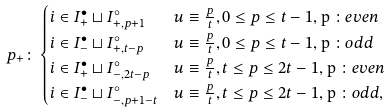Convert formula to latex. <formula><loc_0><loc_0><loc_500><loc_500>p _ { + } \colon & \begin{cases} i \in I ^ { \bullet } _ { + } \sqcup I ^ { \circ } _ { + , p + 1 } & u \equiv \frac { p } { t } , 0 \leq p \leq t - 1 , $ p $ \colon e v e n \\ i \in I ^ { \bullet } _ { - } \sqcup I ^ { \circ } _ { + , t - p } & u \equiv \frac { p } { t } , 0 \leq p \leq t - 1 , $ p $ \colon o d d \\ i \in I ^ { \bullet } _ { + } \sqcup I ^ { \circ } _ { - , 2 t - p } & u \equiv \frac { p } { t } , t \leq p \leq 2 t - 1 , $ p $ \colon e v e n \\ i \in I ^ { \bullet } _ { - } \sqcup I ^ { \circ } _ { - , p + 1 - t } & u \equiv \frac { p } { t } , t \leq p \leq 2 t - 1 , $ p $ \colon o d d , \\ \end{cases}</formula> 